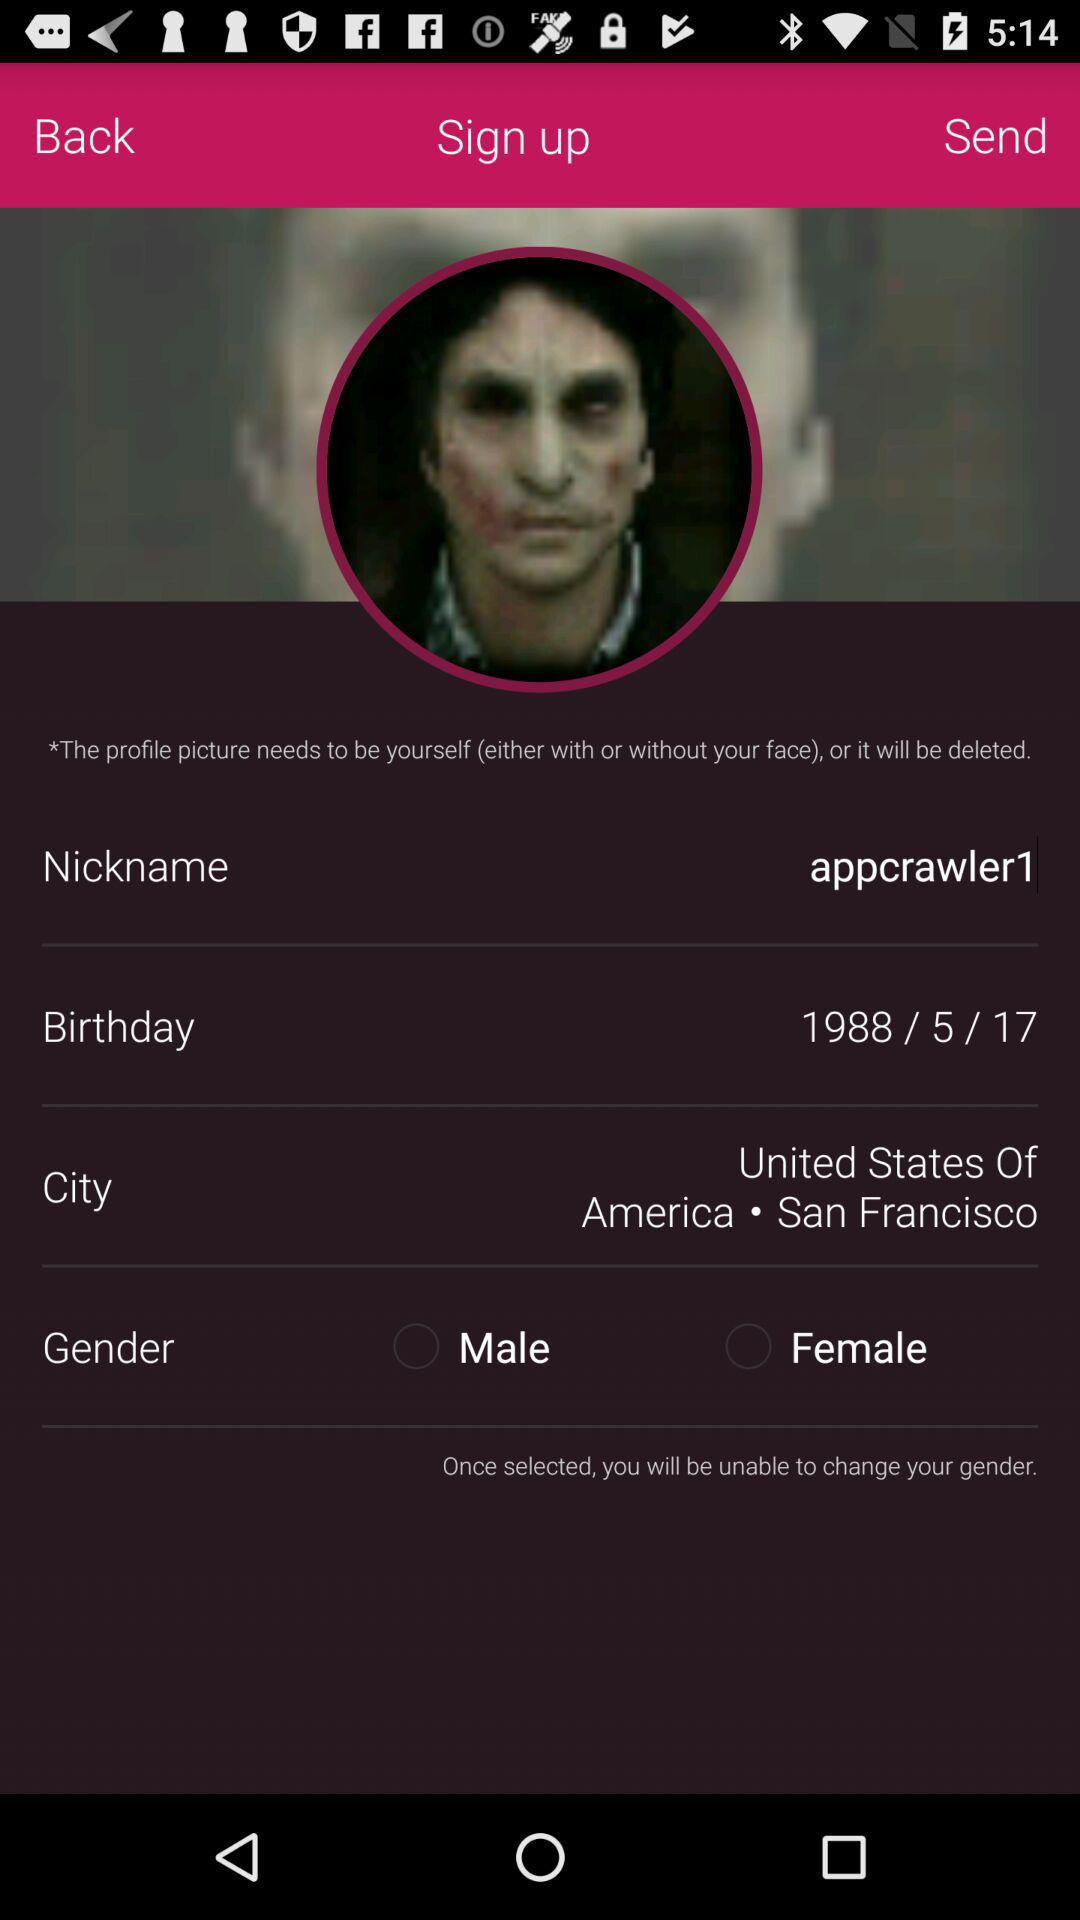What is the selected gender?
When the provided information is insufficient, respond with <no answer>. <no answer> 